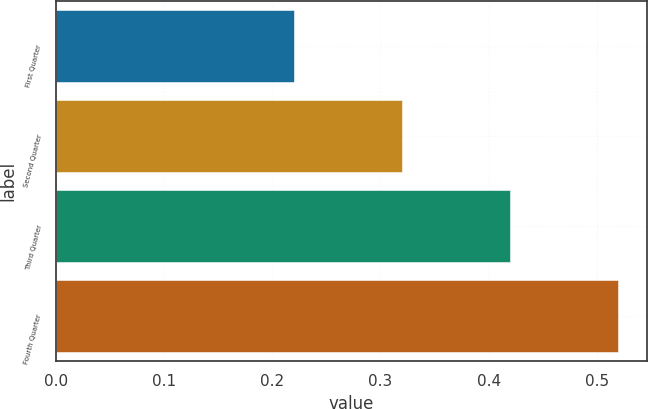<chart> <loc_0><loc_0><loc_500><loc_500><bar_chart><fcel>First Quarter<fcel>Second Quarter<fcel>Third Quarter<fcel>Fourth Quarter<nl><fcel>0.22<fcel>0.32<fcel>0.42<fcel>0.52<nl></chart> 